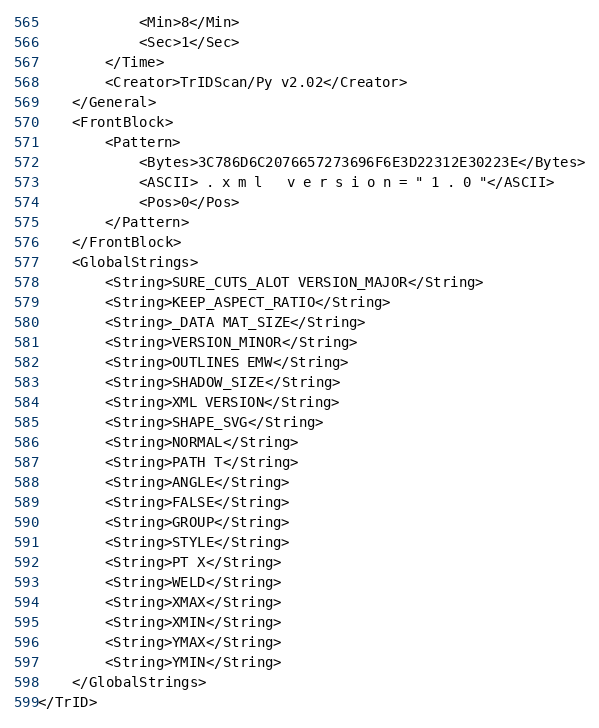<code> <loc_0><loc_0><loc_500><loc_500><_XML_>			<Min>8</Min>
			<Sec>1</Sec>
		</Time>
		<Creator>TrIDScan/Py v2.02</Creator>
	</General>
	<FrontBlock>
		<Pattern>
			<Bytes>3C786D6C2076657273696F6E3D22312E30223E</Bytes>
			<ASCII> . x m l   v e r s i o n = " 1 . 0 "</ASCII>
			<Pos>0</Pos>
		</Pattern>
	</FrontBlock>
	<GlobalStrings>
		<String>SURE_CUTS_ALOT VERSION_MAJOR</String>
		<String>KEEP_ASPECT_RATIO</String>
		<String>_DATA MAT_SIZE</String>
		<String>VERSION_MINOR</String>
		<String>OUTLINES EMW</String>
		<String>SHADOW_SIZE</String>
		<String>XML VERSION</String>
		<String>SHAPE_SVG</String>
		<String>NORMAL</String>
		<String>PATH T</String>
		<String>ANGLE</String>
		<String>FALSE</String>
		<String>GROUP</String>
		<String>STYLE</String>
		<String>PT X</String>
		<String>WELD</String>
		<String>XMAX</String>
		<String>XMIN</String>
		<String>YMAX</String>
		<String>YMIN</String>
	</GlobalStrings>
</TrID></code> 